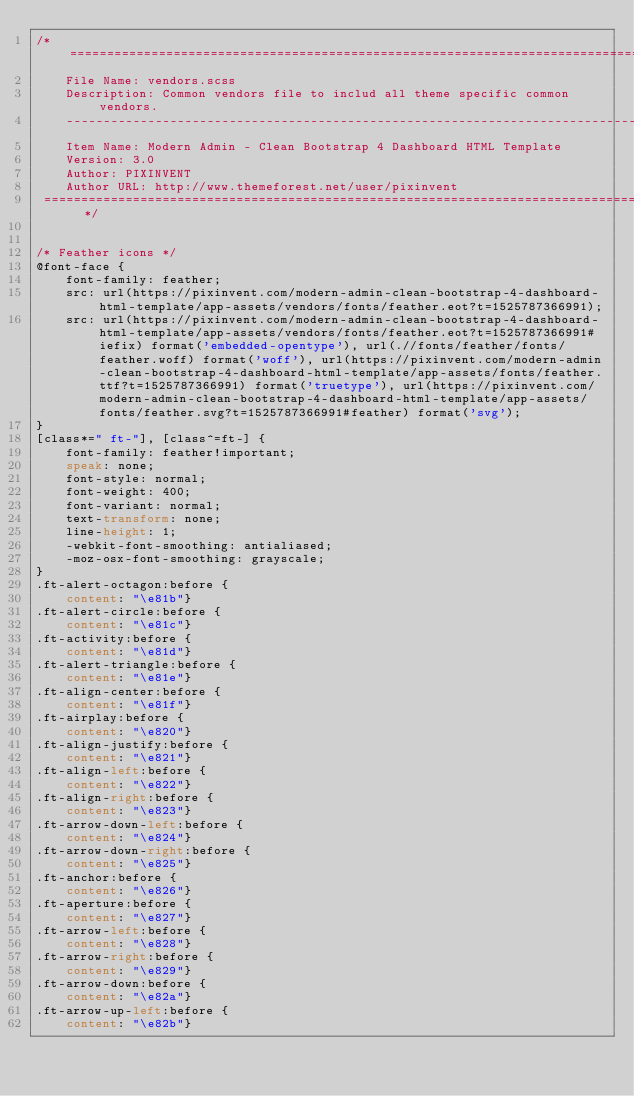<code> <loc_0><loc_0><loc_500><loc_500><_CSS_>/* ================================================================================================
 	File Name: vendors.scss
 	Description: Common vendors file to includ all theme specific common vendors.
 	----------------------------------------------------------------------------------------------
 	Item Name: Modern Admin - Clean Bootstrap 4 Dashboard HTML Template
 	Version: 3.0
 	Author: PIXINVENT
 	Author URL: http://www.themeforest.net/user/pixinvent
 ================================================================================================ */


/* Feather icons */
@font-face {
    font-family: feather;
    src: url(https://pixinvent.com/modern-admin-clean-bootstrap-4-dashboard-html-template/app-assets/vendors/fonts/feather.eot?t=1525787366991);
    src: url(https://pixinvent.com/modern-admin-clean-bootstrap-4-dashboard-html-template/app-assets/vendors/fonts/feather.eot?t=1525787366991#iefix) format('embedded-opentype'), url(.//fonts/feather/fonts/feather.woff) format('woff'), url(https://pixinvent.com/modern-admin-clean-bootstrap-4-dashboard-html-template/app-assets/fonts/feather.ttf?t=1525787366991) format('truetype'), url(https://pixinvent.com/modern-admin-clean-bootstrap-4-dashboard-html-template/app-assets/fonts/feather.svg?t=1525787366991#feather) format('svg');
}
[class*=" ft-"], [class^=ft-] {
    font-family: feather!important;
    speak: none;
    font-style: normal;
    font-weight: 400;
    font-variant: normal;
    text-transform: none;
    line-height: 1;
    -webkit-font-smoothing: antialiased;
    -moz-osx-font-smoothing: grayscale;
}
.ft-alert-octagon:before {
    content: "\e81b"}
.ft-alert-circle:before {
    content: "\e81c"}
.ft-activity:before {
    content: "\e81d"}
.ft-alert-triangle:before {
    content: "\e81e"}
.ft-align-center:before {
    content: "\e81f"}
.ft-airplay:before {
    content: "\e820"}
.ft-align-justify:before {
    content: "\e821"}
.ft-align-left:before {
    content: "\e822"}
.ft-align-right:before {
    content: "\e823"}
.ft-arrow-down-left:before {
    content: "\e824"}
.ft-arrow-down-right:before {
    content: "\e825"}
.ft-anchor:before {
    content: "\e826"}
.ft-aperture:before {
    content: "\e827"}
.ft-arrow-left:before {
    content: "\e828"}
.ft-arrow-right:before {
    content: "\e829"}
.ft-arrow-down:before {
    content: "\e82a"}
.ft-arrow-up-left:before {
    content: "\e82b"}</code> 